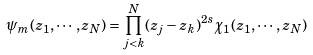<formula> <loc_0><loc_0><loc_500><loc_500>\psi _ { m } ( z _ { 1 } , \cdots , z _ { N } ) = \prod ^ { N } _ { j < k } ( z _ { j } - z _ { k } ) ^ { 2 s } \chi _ { 1 } ( z _ { 1 } , \cdots , z _ { N } )</formula> 